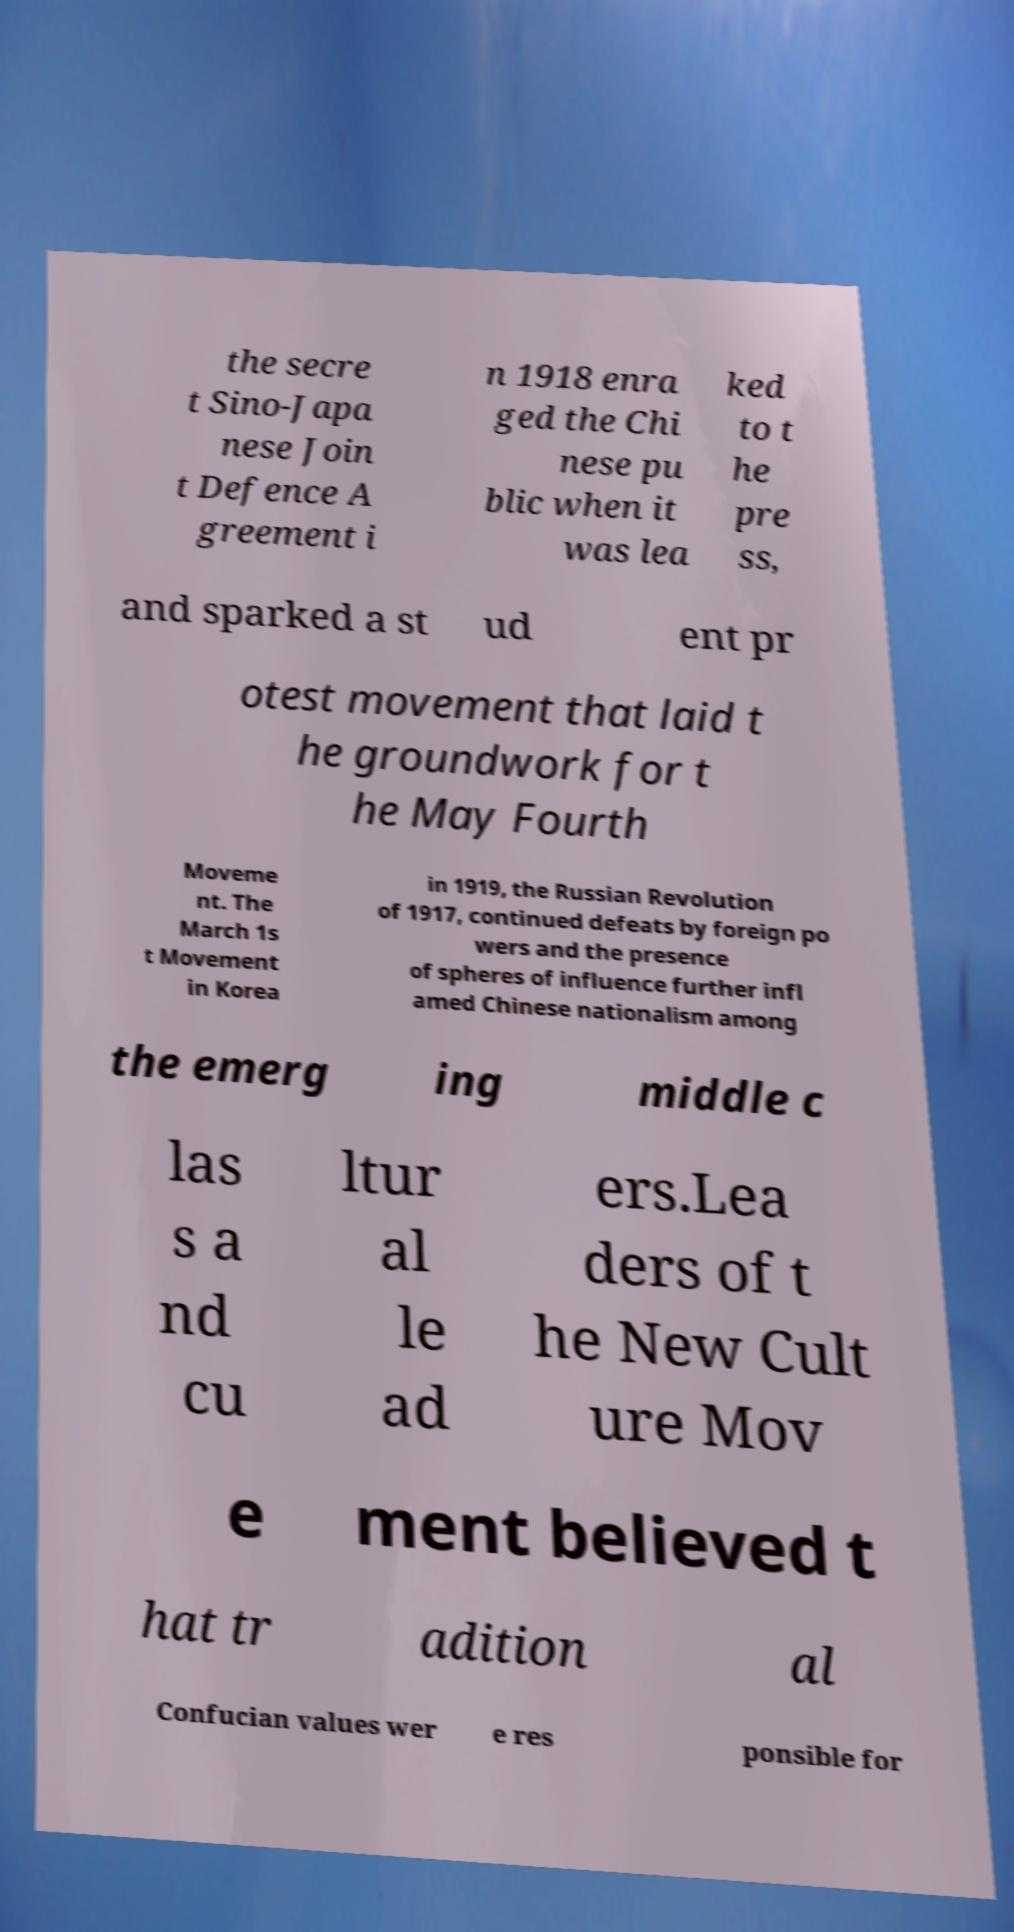Could you assist in decoding the text presented in this image and type it out clearly? the secre t Sino-Japa nese Join t Defence A greement i n 1918 enra ged the Chi nese pu blic when it was lea ked to t he pre ss, and sparked a st ud ent pr otest movement that laid t he groundwork for t he May Fourth Moveme nt. The March 1s t Movement in Korea in 1919, the Russian Revolution of 1917, continued defeats by foreign po wers and the presence of spheres of influence further infl amed Chinese nationalism among the emerg ing middle c las s a nd cu ltur al le ad ers.Lea ders of t he New Cult ure Mov e ment believed t hat tr adition al Confucian values wer e res ponsible for 